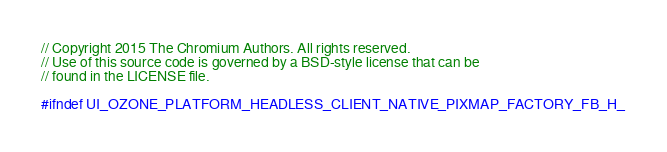<code> <loc_0><loc_0><loc_500><loc_500><_C_>// Copyright 2015 The Chromium Authors. All rights reserved.
// Use of this source code is governed by a BSD-style license that can be
// found in the LICENSE file.

#ifndef UI_OZONE_PLATFORM_HEADLESS_CLIENT_NATIVE_PIXMAP_FACTORY_FB_H_</code> 